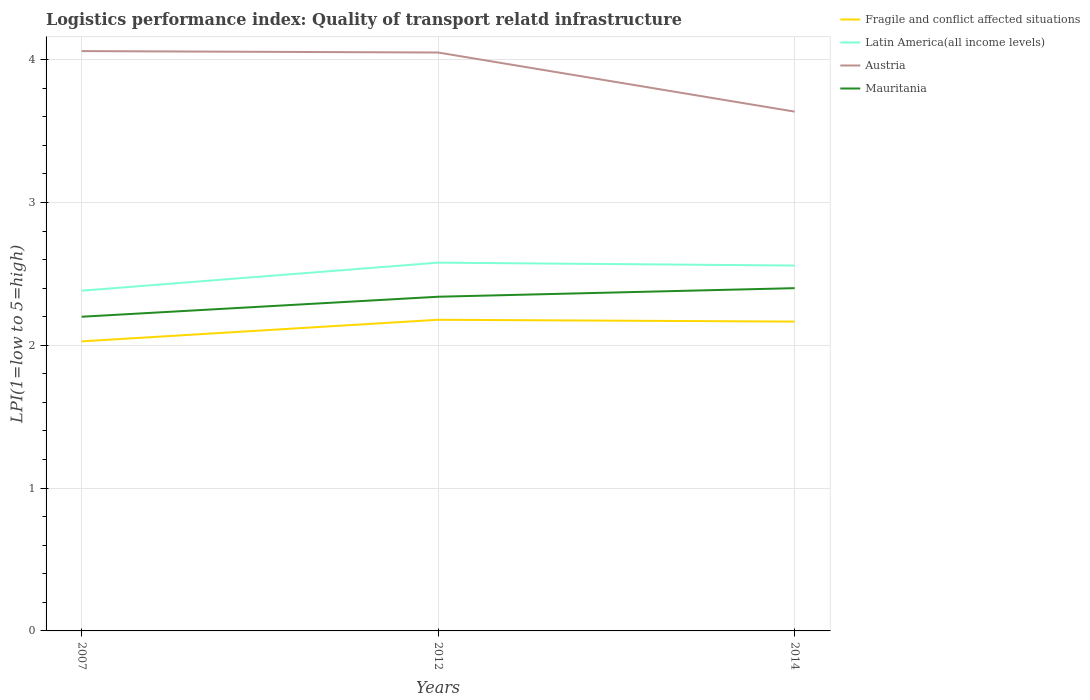How many different coloured lines are there?
Offer a terse response. 4. Does the line corresponding to Mauritania intersect with the line corresponding to Austria?
Ensure brevity in your answer.  No. Is the number of lines equal to the number of legend labels?
Provide a succinct answer. Yes. Across all years, what is the maximum logistics performance index in Mauritania?
Provide a succinct answer. 2.2. What is the total logistics performance index in Fragile and conflict affected situations in the graph?
Your answer should be very brief. -0.14. What is the difference between the highest and the second highest logistics performance index in Mauritania?
Ensure brevity in your answer.  0.2. Is the logistics performance index in Mauritania strictly greater than the logistics performance index in Fragile and conflict affected situations over the years?
Your response must be concise. No. What is the difference between two consecutive major ticks on the Y-axis?
Provide a short and direct response. 1. Does the graph contain any zero values?
Your answer should be very brief. No. How are the legend labels stacked?
Your answer should be very brief. Vertical. What is the title of the graph?
Make the answer very short. Logistics performance index: Quality of transport relatd infrastructure. Does "Burundi" appear as one of the legend labels in the graph?
Provide a succinct answer. No. What is the label or title of the Y-axis?
Offer a very short reply. LPI(1=low to 5=high). What is the LPI(1=low to 5=high) of Fragile and conflict affected situations in 2007?
Offer a very short reply. 2.03. What is the LPI(1=low to 5=high) in Latin America(all income levels) in 2007?
Ensure brevity in your answer.  2.38. What is the LPI(1=low to 5=high) of Austria in 2007?
Offer a very short reply. 4.06. What is the LPI(1=low to 5=high) of Mauritania in 2007?
Your answer should be compact. 2.2. What is the LPI(1=low to 5=high) of Fragile and conflict affected situations in 2012?
Give a very brief answer. 2.18. What is the LPI(1=low to 5=high) of Latin America(all income levels) in 2012?
Ensure brevity in your answer.  2.58. What is the LPI(1=low to 5=high) in Austria in 2012?
Make the answer very short. 4.05. What is the LPI(1=low to 5=high) of Mauritania in 2012?
Give a very brief answer. 2.34. What is the LPI(1=low to 5=high) of Fragile and conflict affected situations in 2014?
Provide a succinct answer. 2.17. What is the LPI(1=low to 5=high) in Latin America(all income levels) in 2014?
Ensure brevity in your answer.  2.56. What is the LPI(1=low to 5=high) of Austria in 2014?
Keep it short and to the point. 3.64. What is the LPI(1=low to 5=high) in Mauritania in 2014?
Your answer should be compact. 2.4. Across all years, what is the maximum LPI(1=low to 5=high) in Fragile and conflict affected situations?
Make the answer very short. 2.18. Across all years, what is the maximum LPI(1=low to 5=high) of Latin America(all income levels)?
Your answer should be very brief. 2.58. Across all years, what is the maximum LPI(1=low to 5=high) in Austria?
Make the answer very short. 4.06. Across all years, what is the minimum LPI(1=low to 5=high) of Fragile and conflict affected situations?
Give a very brief answer. 2.03. Across all years, what is the minimum LPI(1=low to 5=high) in Latin America(all income levels)?
Provide a short and direct response. 2.38. Across all years, what is the minimum LPI(1=low to 5=high) in Austria?
Ensure brevity in your answer.  3.64. Across all years, what is the minimum LPI(1=low to 5=high) in Mauritania?
Your answer should be compact. 2.2. What is the total LPI(1=low to 5=high) of Fragile and conflict affected situations in the graph?
Keep it short and to the point. 6.37. What is the total LPI(1=low to 5=high) of Latin America(all income levels) in the graph?
Your answer should be very brief. 7.52. What is the total LPI(1=low to 5=high) of Austria in the graph?
Your answer should be very brief. 11.75. What is the total LPI(1=low to 5=high) of Mauritania in the graph?
Ensure brevity in your answer.  6.94. What is the difference between the LPI(1=low to 5=high) of Fragile and conflict affected situations in 2007 and that in 2012?
Provide a succinct answer. -0.15. What is the difference between the LPI(1=low to 5=high) in Latin America(all income levels) in 2007 and that in 2012?
Provide a short and direct response. -0.2. What is the difference between the LPI(1=low to 5=high) in Mauritania in 2007 and that in 2012?
Provide a short and direct response. -0.14. What is the difference between the LPI(1=low to 5=high) in Fragile and conflict affected situations in 2007 and that in 2014?
Offer a terse response. -0.14. What is the difference between the LPI(1=low to 5=high) of Latin America(all income levels) in 2007 and that in 2014?
Provide a succinct answer. -0.18. What is the difference between the LPI(1=low to 5=high) in Austria in 2007 and that in 2014?
Offer a terse response. 0.42. What is the difference between the LPI(1=low to 5=high) of Fragile and conflict affected situations in 2012 and that in 2014?
Provide a succinct answer. 0.01. What is the difference between the LPI(1=low to 5=high) in Latin America(all income levels) in 2012 and that in 2014?
Give a very brief answer. 0.02. What is the difference between the LPI(1=low to 5=high) of Austria in 2012 and that in 2014?
Offer a terse response. 0.41. What is the difference between the LPI(1=low to 5=high) of Mauritania in 2012 and that in 2014?
Provide a short and direct response. -0.06. What is the difference between the LPI(1=low to 5=high) of Fragile and conflict affected situations in 2007 and the LPI(1=low to 5=high) of Latin America(all income levels) in 2012?
Your response must be concise. -0.55. What is the difference between the LPI(1=low to 5=high) of Fragile and conflict affected situations in 2007 and the LPI(1=low to 5=high) of Austria in 2012?
Your answer should be compact. -2.02. What is the difference between the LPI(1=low to 5=high) in Fragile and conflict affected situations in 2007 and the LPI(1=low to 5=high) in Mauritania in 2012?
Provide a succinct answer. -0.31. What is the difference between the LPI(1=low to 5=high) of Latin America(all income levels) in 2007 and the LPI(1=low to 5=high) of Austria in 2012?
Provide a short and direct response. -1.67. What is the difference between the LPI(1=low to 5=high) of Latin America(all income levels) in 2007 and the LPI(1=low to 5=high) of Mauritania in 2012?
Provide a short and direct response. 0.04. What is the difference between the LPI(1=low to 5=high) in Austria in 2007 and the LPI(1=low to 5=high) in Mauritania in 2012?
Make the answer very short. 1.72. What is the difference between the LPI(1=low to 5=high) in Fragile and conflict affected situations in 2007 and the LPI(1=low to 5=high) in Latin America(all income levels) in 2014?
Provide a succinct answer. -0.53. What is the difference between the LPI(1=low to 5=high) of Fragile and conflict affected situations in 2007 and the LPI(1=low to 5=high) of Austria in 2014?
Offer a terse response. -1.61. What is the difference between the LPI(1=low to 5=high) in Fragile and conflict affected situations in 2007 and the LPI(1=low to 5=high) in Mauritania in 2014?
Your answer should be very brief. -0.37. What is the difference between the LPI(1=low to 5=high) of Latin America(all income levels) in 2007 and the LPI(1=low to 5=high) of Austria in 2014?
Your answer should be very brief. -1.25. What is the difference between the LPI(1=low to 5=high) of Latin America(all income levels) in 2007 and the LPI(1=low to 5=high) of Mauritania in 2014?
Your answer should be very brief. -0.02. What is the difference between the LPI(1=low to 5=high) in Austria in 2007 and the LPI(1=low to 5=high) in Mauritania in 2014?
Offer a terse response. 1.66. What is the difference between the LPI(1=low to 5=high) in Fragile and conflict affected situations in 2012 and the LPI(1=low to 5=high) in Latin America(all income levels) in 2014?
Your answer should be compact. -0.38. What is the difference between the LPI(1=low to 5=high) in Fragile and conflict affected situations in 2012 and the LPI(1=low to 5=high) in Austria in 2014?
Your response must be concise. -1.46. What is the difference between the LPI(1=low to 5=high) of Fragile and conflict affected situations in 2012 and the LPI(1=low to 5=high) of Mauritania in 2014?
Your answer should be compact. -0.22. What is the difference between the LPI(1=low to 5=high) of Latin America(all income levels) in 2012 and the LPI(1=low to 5=high) of Austria in 2014?
Your answer should be compact. -1.06. What is the difference between the LPI(1=low to 5=high) in Latin America(all income levels) in 2012 and the LPI(1=low to 5=high) in Mauritania in 2014?
Your answer should be compact. 0.18. What is the difference between the LPI(1=low to 5=high) of Austria in 2012 and the LPI(1=low to 5=high) of Mauritania in 2014?
Provide a short and direct response. 1.65. What is the average LPI(1=low to 5=high) in Fragile and conflict affected situations per year?
Make the answer very short. 2.12. What is the average LPI(1=low to 5=high) of Latin America(all income levels) per year?
Give a very brief answer. 2.51. What is the average LPI(1=low to 5=high) of Austria per year?
Provide a succinct answer. 3.92. What is the average LPI(1=low to 5=high) of Mauritania per year?
Keep it short and to the point. 2.31. In the year 2007, what is the difference between the LPI(1=low to 5=high) of Fragile and conflict affected situations and LPI(1=low to 5=high) of Latin America(all income levels)?
Ensure brevity in your answer.  -0.35. In the year 2007, what is the difference between the LPI(1=low to 5=high) of Fragile and conflict affected situations and LPI(1=low to 5=high) of Austria?
Provide a short and direct response. -2.03. In the year 2007, what is the difference between the LPI(1=low to 5=high) of Fragile and conflict affected situations and LPI(1=low to 5=high) of Mauritania?
Offer a terse response. -0.17. In the year 2007, what is the difference between the LPI(1=low to 5=high) in Latin America(all income levels) and LPI(1=low to 5=high) in Austria?
Provide a succinct answer. -1.68. In the year 2007, what is the difference between the LPI(1=low to 5=high) of Latin America(all income levels) and LPI(1=low to 5=high) of Mauritania?
Offer a very short reply. 0.18. In the year 2007, what is the difference between the LPI(1=low to 5=high) in Austria and LPI(1=low to 5=high) in Mauritania?
Provide a succinct answer. 1.86. In the year 2012, what is the difference between the LPI(1=low to 5=high) of Fragile and conflict affected situations and LPI(1=low to 5=high) of Latin America(all income levels)?
Offer a terse response. -0.4. In the year 2012, what is the difference between the LPI(1=low to 5=high) of Fragile and conflict affected situations and LPI(1=low to 5=high) of Austria?
Give a very brief answer. -1.87. In the year 2012, what is the difference between the LPI(1=low to 5=high) in Fragile and conflict affected situations and LPI(1=low to 5=high) in Mauritania?
Make the answer very short. -0.16. In the year 2012, what is the difference between the LPI(1=low to 5=high) in Latin America(all income levels) and LPI(1=low to 5=high) in Austria?
Your response must be concise. -1.47. In the year 2012, what is the difference between the LPI(1=low to 5=high) in Latin America(all income levels) and LPI(1=low to 5=high) in Mauritania?
Your response must be concise. 0.24. In the year 2012, what is the difference between the LPI(1=low to 5=high) of Austria and LPI(1=low to 5=high) of Mauritania?
Keep it short and to the point. 1.71. In the year 2014, what is the difference between the LPI(1=low to 5=high) of Fragile and conflict affected situations and LPI(1=low to 5=high) of Latin America(all income levels)?
Ensure brevity in your answer.  -0.39. In the year 2014, what is the difference between the LPI(1=low to 5=high) of Fragile and conflict affected situations and LPI(1=low to 5=high) of Austria?
Your answer should be very brief. -1.47. In the year 2014, what is the difference between the LPI(1=low to 5=high) of Fragile and conflict affected situations and LPI(1=low to 5=high) of Mauritania?
Make the answer very short. -0.23. In the year 2014, what is the difference between the LPI(1=low to 5=high) of Latin America(all income levels) and LPI(1=low to 5=high) of Austria?
Your response must be concise. -1.08. In the year 2014, what is the difference between the LPI(1=low to 5=high) of Latin America(all income levels) and LPI(1=low to 5=high) of Mauritania?
Your answer should be very brief. 0.16. In the year 2014, what is the difference between the LPI(1=low to 5=high) of Austria and LPI(1=low to 5=high) of Mauritania?
Offer a very short reply. 1.24. What is the ratio of the LPI(1=low to 5=high) in Fragile and conflict affected situations in 2007 to that in 2012?
Offer a terse response. 0.93. What is the ratio of the LPI(1=low to 5=high) in Latin America(all income levels) in 2007 to that in 2012?
Provide a succinct answer. 0.92. What is the ratio of the LPI(1=low to 5=high) in Austria in 2007 to that in 2012?
Your answer should be very brief. 1. What is the ratio of the LPI(1=low to 5=high) in Mauritania in 2007 to that in 2012?
Your answer should be very brief. 0.94. What is the ratio of the LPI(1=low to 5=high) in Fragile and conflict affected situations in 2007 to that in 2014?
Ensure brevity in your answer.  0.94. What is the ratio of the LPI(1=low to 5=high) of Latin America(all income levels) in 2007 to that in 2014?
Offer a very short reply. 0.93. What is the ratio of the LPI(1=low to 5=high) of Austria in 2007 to that in 2014?
Your answer should be very brief. 1.12. What is the ratio of the LPI(1=low to 5=high) in Fragile and conflict affected situations in 2012 to that in 2014?
Ensure brevity in your answer.  1.01. What is the ratio of the LPI(1=low to 5=high) in Latin America(all income levels) in 2012 to that in 2014?
Offer a terse response. 1.01. What is the ratio of the LPI(1=low to 5=high) of Austria in 2012 to that in 2014?
Your response must be concise. 1.11. What is the difference between the highest and the second highest LPI(1=low to 5=high) of Fragile and conflict affected situations?
Your answer should be very brief. 0.01. What is the difference between the highest and the second highest LPI(1=low to 5=high) of Latin America(all income levels)?
Provide a short and direct response. 0.02. What is the difference between the highest and the lowest LPI(1=low to 5=high) of Fragile and conflict affected situations?
Provide a succinct answer. 0.15. What is the difference between the highest and the lowest LPI(1=low to 5=high) of Latin America(all income levels)?
Offer a very short reply. 0.2. What is the difference between the highest and the lowest LPI(1=low to 5=high) in Austria?
Provide a succinct answer. 0.42. What is the difference between the highest and the lowest LPI(1=low to 5=high) in Mauritania?
Your answer should be very brief. 0.2. 